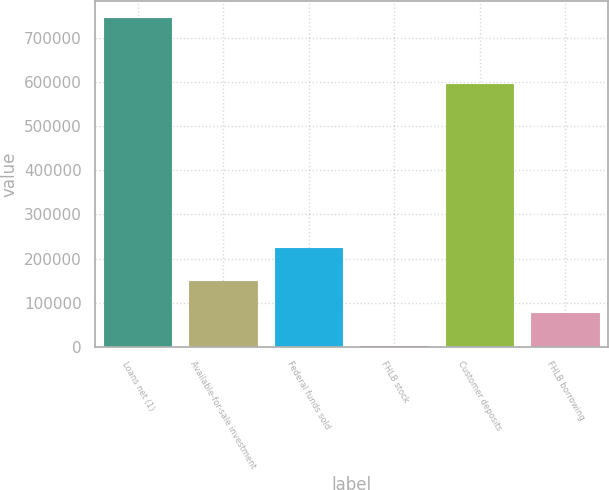Convert chart to OTSL. <chart><loc_0><loc_0><loc_500><loc_500><bar_chart><fcel>Loans net (1)<fcel>Available-for-sale investment<fcel>Federal funds sold<fcel>FHLB stock<fcel>Customer deposits<fcel>FHLB borrowing<nl><fcel>746387<fcel>150053<fcel>224595<fcel>970<fcel>596104<fcel>75511.7<nl></chart> 